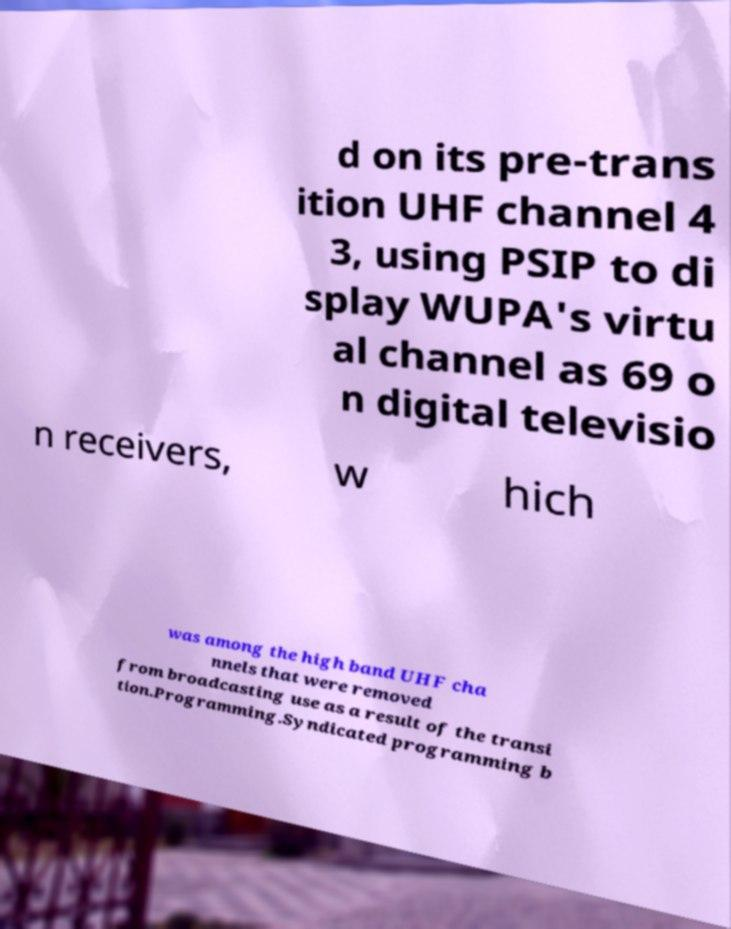For documentation purposes, I need the text within this image transcribed. Could you provide that? d on its pre-trans ition UHF channel 4 3, using PSIP to di splay WUPA's virtu al channel as 69 o n digital televisio n receivers, w hich was among the high band UHF cha nnels that were removed from broadcasting use as a result of the transi tion.Programming.Syndicated programming b 